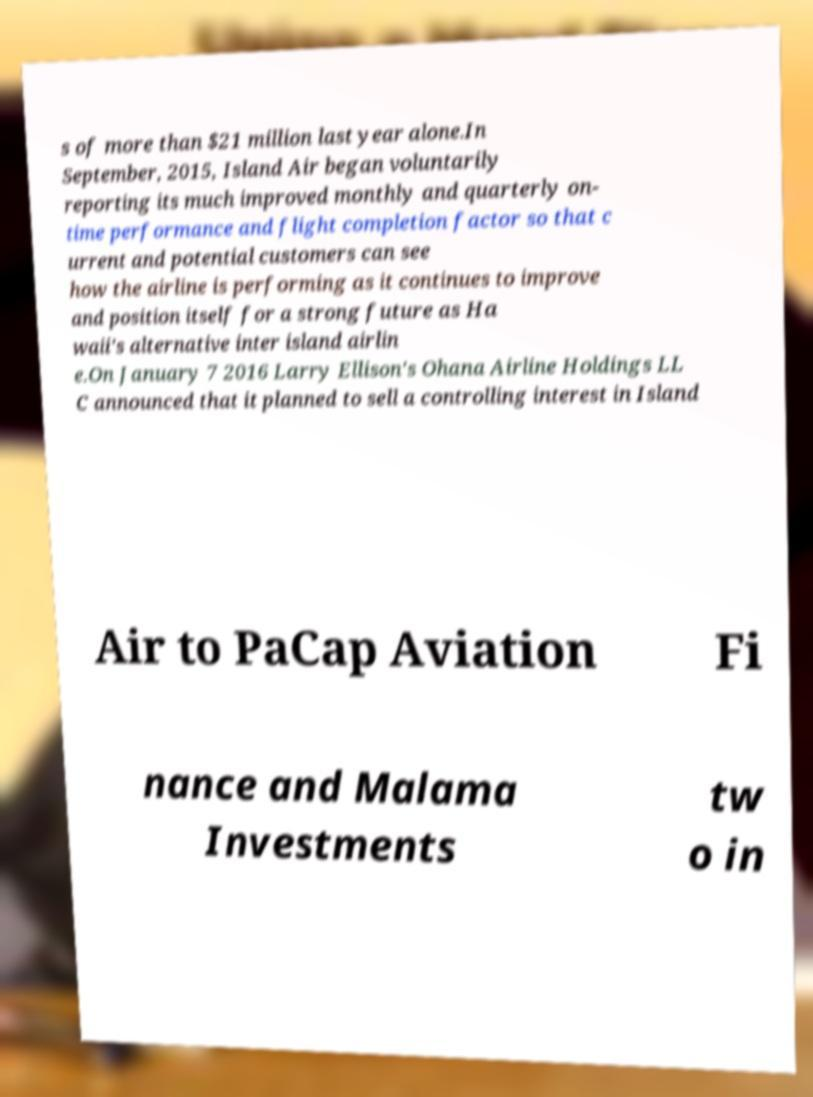I need the written content from this picture converted into text. Can you do that? s of more than $21 million last year alone.In September, 2015, Island Air began voluntarily reporting its much improved monthly and quarterly on- time performance and flight completion factor so that c urrent and potential customers can see how the airline is performing as it continues to improve and position itself for a strong future as Ha waii's alternative inter island airlin e.On January 7 2016 Larry Ellison's Ohana Airline Holdings LL C announced that it planned to sell a controlling interest in Island Air to PaCap Aviation Fi nance and Malama Investments tw o in 